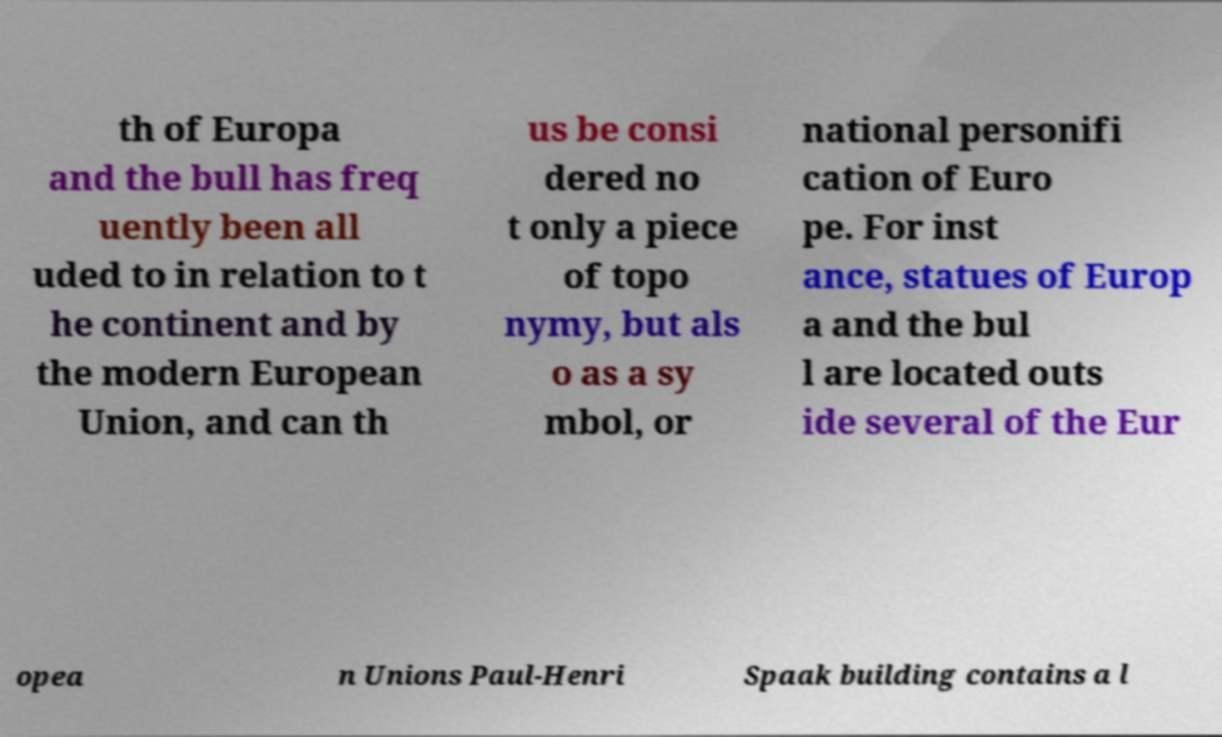Can you read and provide the text displayed in the image?This photo seems to have some interesting text. Can you extract and type it out for me? th of Europa and the bull has freq uently been all uded to in relation to t he continent and by the modern European Union, and can th us be consi dered no t only a piece of topo nymy, but als o as a sy mbol, or national personifi cation of Euro pe. For inst ance, statues of Europ a and the bul l are located outs ide several of the Eur opea n Unions Paul-Henri Spaak building contains a l 